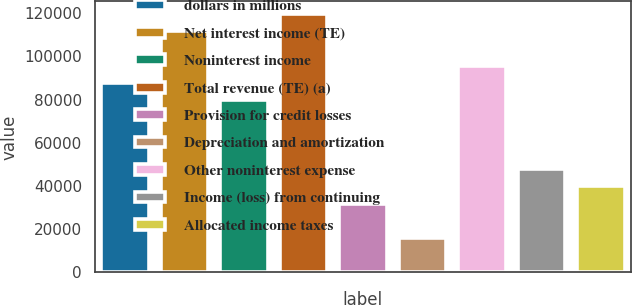<chart> <loc_0><loc_0><loc_500><loc_500><bar_chart><fcel>dollars in millions<fcel>Net interest income (TE)<fcel>Noninterest income<fcel>Total revenue (TE) (a)<fcel>Provision for credit losses<fcel>Depreciation and amortization<fcel>Other noninterest expense<fcel>Income (loss) from continuing<fcel>Allocated income taxes<nl><fcel>87634.5<fcel>111531<fcel>79669<fcel>119497<fcel>31875.8<fcel>15944.8<fcel>95600.1<fcel>47806.9<fcel>39841.4<nl></chart> 